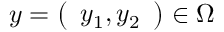Convert formula to latex. <formula><loc_0><loc_0><loc_500><loc_500>y = \left ( \begin{array} { l } { y _ { 1 } , y _ { 2 } } \end{array} \right ) \in \Omega</formula> 